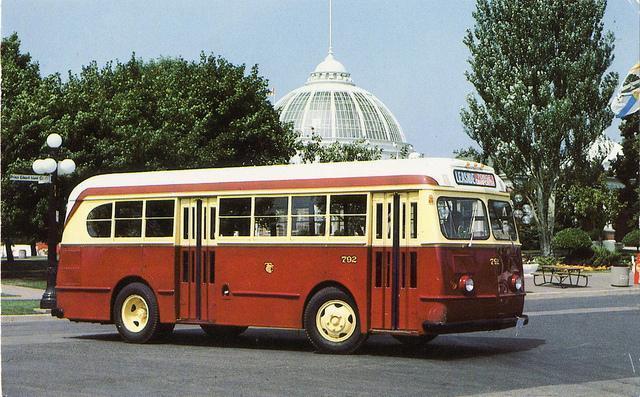How many wheels does the bus have?
Give a very brief answer. 4. How many buses are in the photo?
Give a very brief answer. 1. 